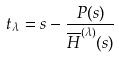Convert formula to latex. <formula><loc_0><loc_0><loc_500><loc_500>t _ { \lambda } = s - \frac { P ( s ) } { \overline { H } ^ { ( \lambda ) } ( s ) }</formula> 